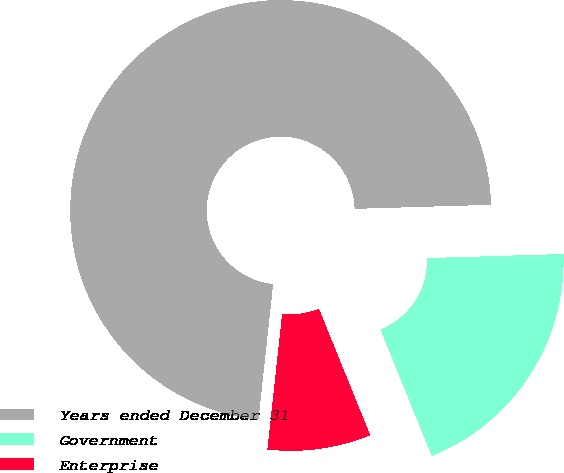Convert chart to OTSL. <chart><loc_0><loc_0><loc_500><loc_500><pie_chart><fcel>Years ended December 31<fcel>Government<fcel>Enterprise<nl><fcel>72.8%<fcel>19.34%<fcel>7.86%<nl></chart> 